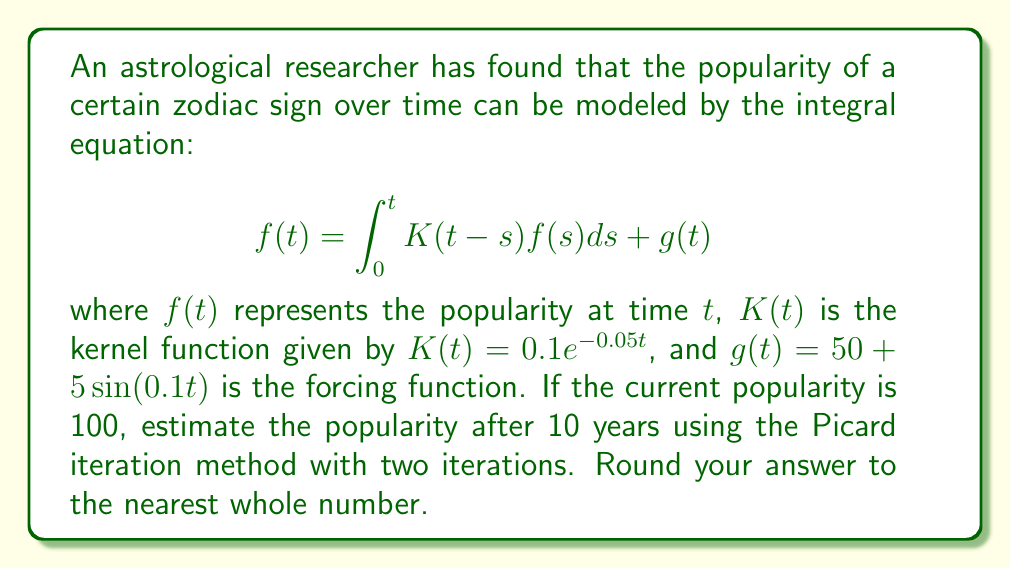Can you solve this math problem? To solve this problem, we'll use the Picard iteration method:

1) First iteration: $f_1(t) = g(t)$
2) Second iteration: $f_2(t) = \int_0^t K(t-s)f_1(s)ds + g(t)$

Step 1: Calculate $f_1(t)$
$$f_1(t) = g(t) = 50 + 5\sin(0.1t)$$

Step 2: Calculate $f_2(t)$
$$\begin{align}
f_2(t) &= \int_0^t K(t-s)f_1(s)ds + g(t) \\
&= \int_0^t 0.1e^{-0.05(t-s)}(50 + 5\sin(0.1s))ds + 50 + 5\sin(0.1t)
\end{align}$$

Step 3: Evaluate the integral
$$\begin{align}
f_2(t) &= 0.1e^{-0.05t}\int_0^t e^{0.05s}(50 + 5\sin(0.1s))ds + 50 + 5\sin(0.1t) \\
&= 0.1e^{-0.05t}[1000(e^{0.05t} - 1) - \frac{5}{0.0101}(0.05\cos(0.1t) + 0.1\sin(0.1t) - 0.05)] + 50 + 5\sin(0.1t)
\end{align}$$

Step 4: Evaluate $f_2(10)$
$$\begin{align}
f_2(10) &≈ 0.1e^{-0.5}[1000(e^{0.5} - 1) - \frac{5}{0.0101}(0.05\cos(1) + 0.1\sin(1) - 0.05)] + 50 + 5\sin(1) \\
&≈ 98.79
\end{align}$$

Step 5: Round to the nearest whole number
$$f_2(10) ≈ 99$$
Answer: 99 